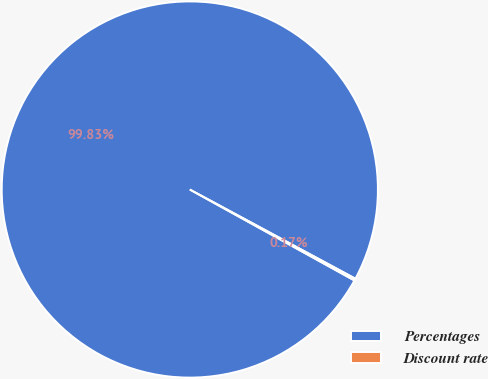Convert chart. <chart><loc_0><loc_0><loc_500><loc_500><pie_chart><fcel>Percentages<fcel>Discount rate<nl><fcel>99.83%<fcel>0.17%<nl></chart> 